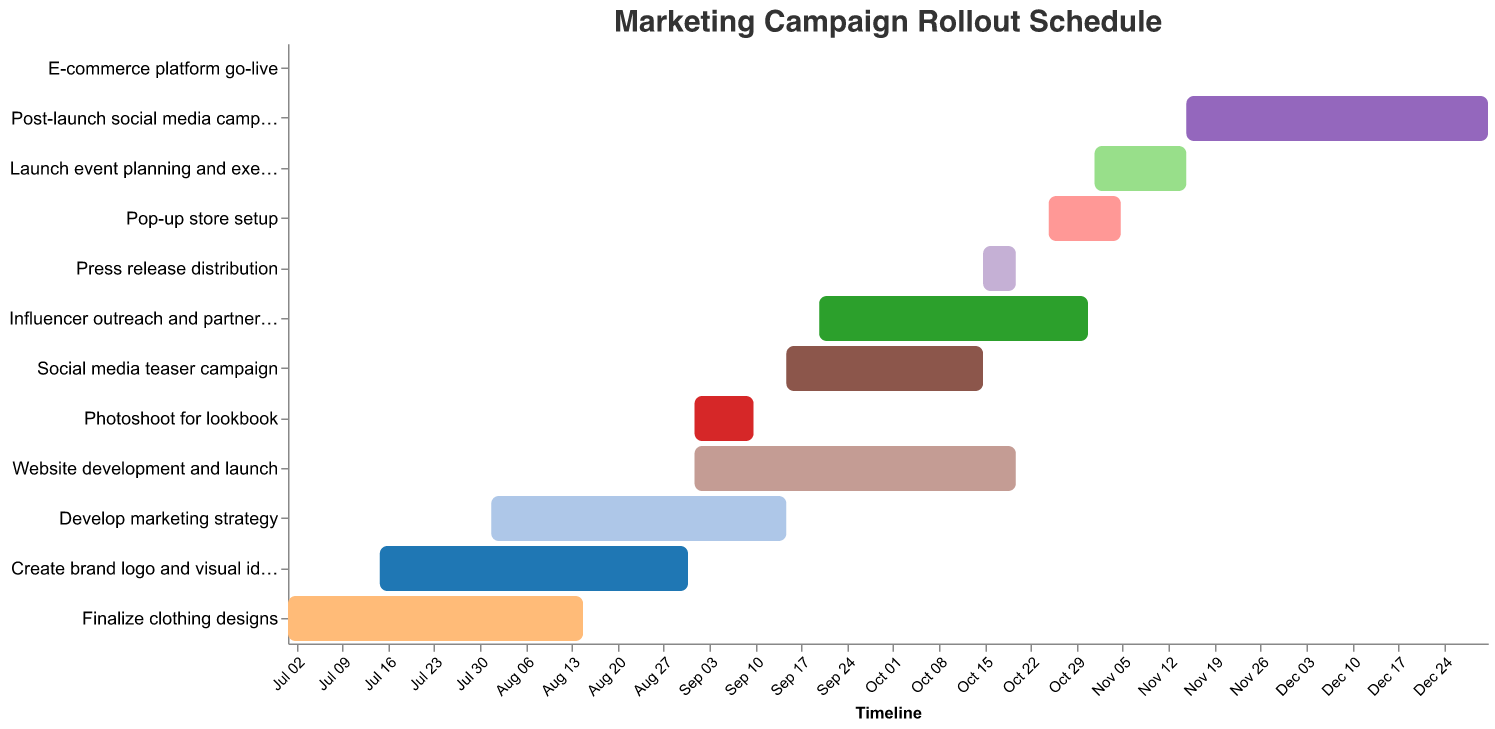What is the title of the Gantt chart? The title is located at the top of the figure and reads "Marketing Campaign Rollout Schedule."
Answer: Marketing Campaign Rollout Schedule When does the task "Finalize clothing designs" start and end? The start and end dates for "Finalize clothing designs" are listed in the Gantt chart. It starts on July 1, 2023, and ends on August 15, 2023.
Answer: July 1, 2023 to August 15, 2023 Which task has the longest duration? To determine the task with the longest duration, calculate the duration for each task by finding the difference between the end date and the start date, then compare the durations. "Post-launch social media campaign" spans from November 15, 2023, to December 31, 2023, which is 47 days, making it the longest task.
Answer: Post-launch social media campaign Which tasks are scheduled to start in September 2023? To identify tasks starting in September 2023, look for tasks with start dates within that month. The tasks are "Photoshoot for lookbook" (September 1), "Social media teaser campaign" (September 15), "Influencer outreach and partnerships" (September 20), and "Website development and launch" (September 1).
Answer: Photoshoot for lookbook, Social media teaser campaign, Influencer outreach and partnerships, Website development and launch What is the overlap period between the "Influencer outreach and partnerships" and "Website development and launch"? First, determine the dates: "Influencer outreach and partnerships" runs from September 20, 2023, to October 31, 2023, while "Website development and launch" is from September 1, 2023, to October 20, 2023. The overlapping period is from September 20, 2023 (the later start) to October 20, 2023 (the earlier end), which is 31 days.
Answer: September 20, 2023 to October 20, 2023 What are the key tasks scheduled for October 2023? Identify tasks that either start or end in October 2023 or span the entire month. The key tasks are "Social media teaser campaign" (September 15 to October 15), "Influencer outreach and partnerships" (September 20 to October 31), "Website development and launch" (September 1 to October 20), and "Press release distribution" (October 15 to October 20).
Answer: Social media teaser campaign, Influencer outreach and partnerships, Website development and launch, Press release distribution Which tasks are still in progress at the end of September 2023? Tasks in progress at the end of September must have start dates before and end dates after September 30, 2023. These tasks are "Influencer outreach and partnerships" (September 20 to October 31), and "Website development and launch" (September 1 to October 20).
Answer: Influencer outreach and partnerships, Website development and launch What is the duration of the "Pop-up store setup" task? Calculate the duration by counting the days between the start date (October 25, 2023) and the end date (November 5, 2023). The duration is 12 days.
Answer: 12 days Which task is scheduled to take place immediately before the "Launch event planning and execution"? Review the end date of the task preceding "Launch event planning and execution" which starts on November 1, 2023. The preceding task is "Pop-up store setup" ending on November 5, 2023.
Answer: Pop-up store setup 